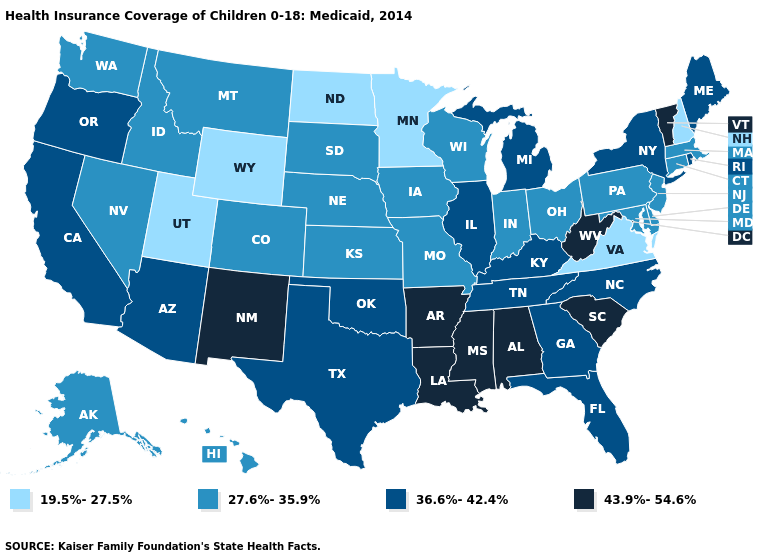Which states hav the highest value in the Northeast?
Answer briefly. Vermont. Does the first symbol in the legend represent the smallest category?
Keep it brief. Yes. What is the value of Arizona?
Be succinct. 36.6%-42.4%. Does the first symbol in the legend represent the smallest category?
Quick response, please. Yes. Name the states that have a value in the range 36.6%-42.4%?
Short answer required. Arizona, California, Florida, Georgia, Illinois, Kentucky, Maine, Michigan, New York, North Carolina, Oklahoma, Oregon, Rhode Island, Tennessee, Texas. Does the first symbol in the legend represent the smallest category?
Answer briefly. Yes. Does Wyoming have the lowest value in the West?
Concise answer only. Yes. Name the states that have a value in the range 43.9%-54.6%?
Keep it brief. Alabama, Arkansas, Louisiana, Mississippi, New Mexico, South Carolina, Vermont, West Virginia. Among the states that border Louisiana , does Arkansas have the highest value?
Keep it brief. Yes. What is the lowest value in the USA?
Quick response, please. 19.5%-27.5%. What is the value of North Dakota?
Short answer required. 19.5%-27.5%. What is the highest value in the USA?
Give a very brief answer. 43.9%-54.6%. Name the states that have a value in the range 27.6%-35.9%?
Keep it brief. Alaska, Colorado, Connecticut, Delaware, Hawaii, Idaho, Indiana, Iowa, Kansas, Maryland, Massachusetts, Missouri, Montana, Nebraska, Nevada, New Jersey, Ohio, Pennsylvania, South Dakota, Washington, Wisconsin. Does New Mexico have the lowest value in the West?
Short answer required. No. What is the value of Illinois?
Be succinct. 36.6%-42.4%. 